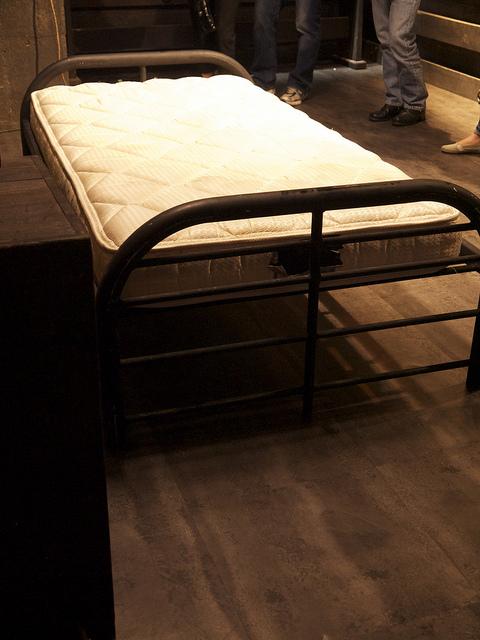Is that a metal bed frame?
Be succinct. Yes. Does the bed have sheets on it?
Give a very brief answer. No. Would this bed be comfortable?
Give a very brief answer. No. 